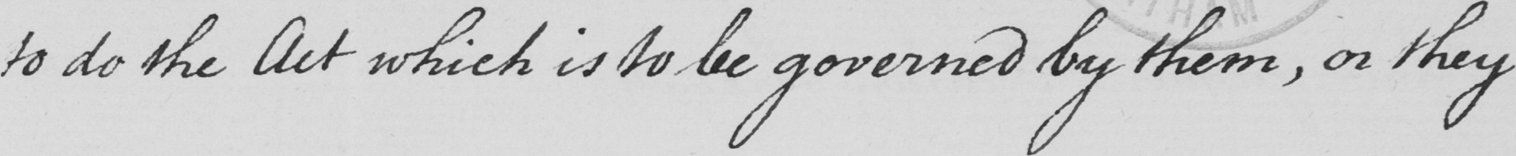What does this handwritten line say? to do the Act which is to be governed by them , or they 